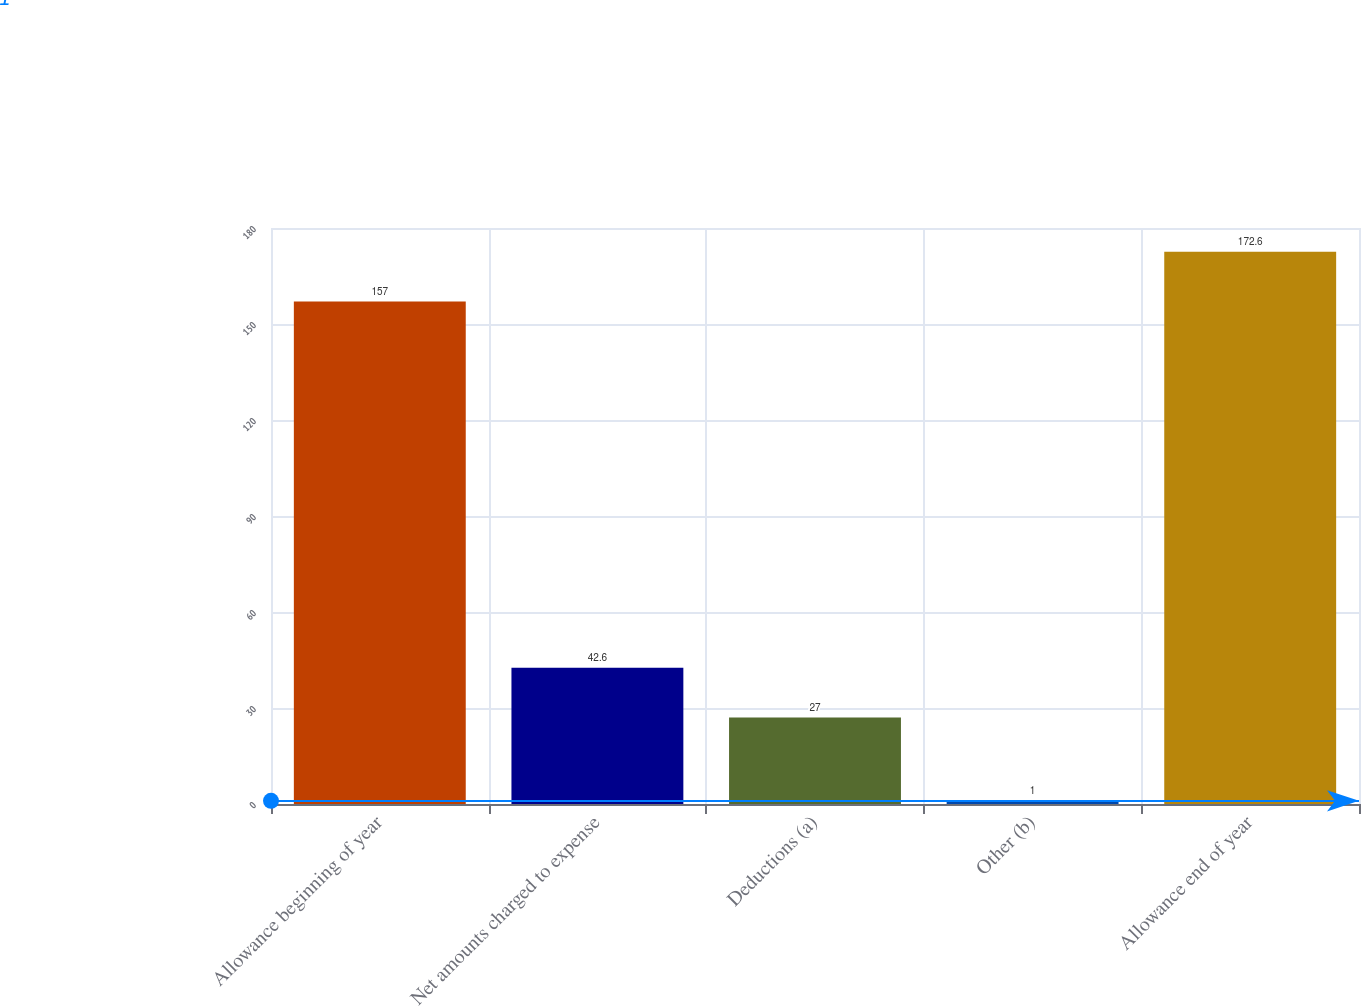Convert chart to OTSL. <chart><loc_0><loc_0><loc_500><loc_500><bar_chart><fcel>Allowance beginning of year<fcel>Net amounts charged to expense<fcel>Deductions (a)<fcel>Other (b)<fcel>Allowance end of year<nl><fcel>157<fcel>42.6<fcel>27<fcel>1<fcel>172.6<nl></chart> 